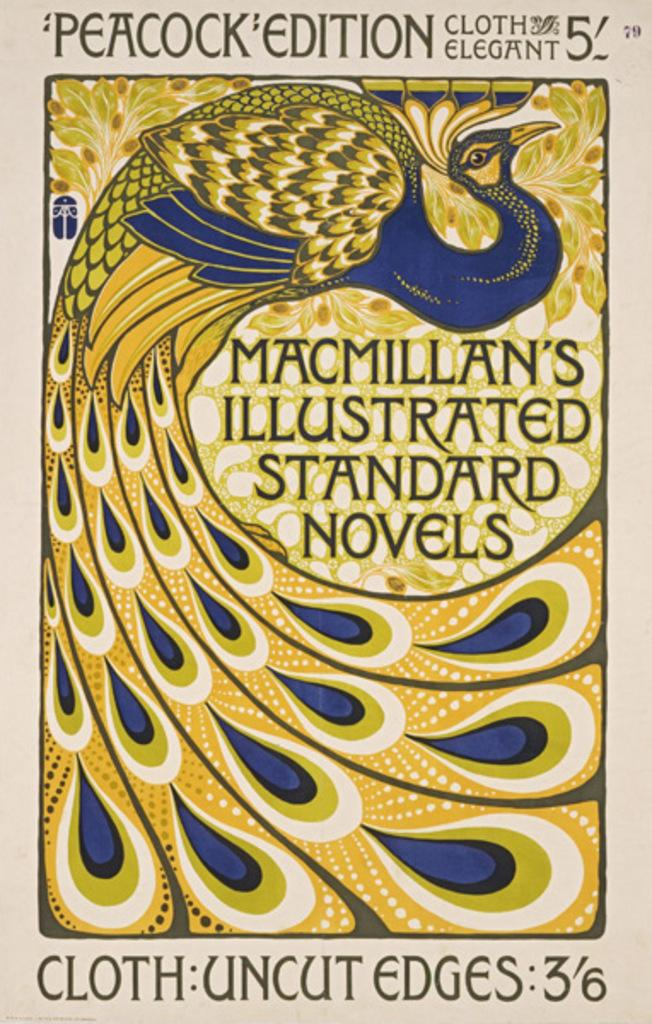<image>
Relay a brief, clear account of the picture shown. a book with a peacock that is called standard novels 